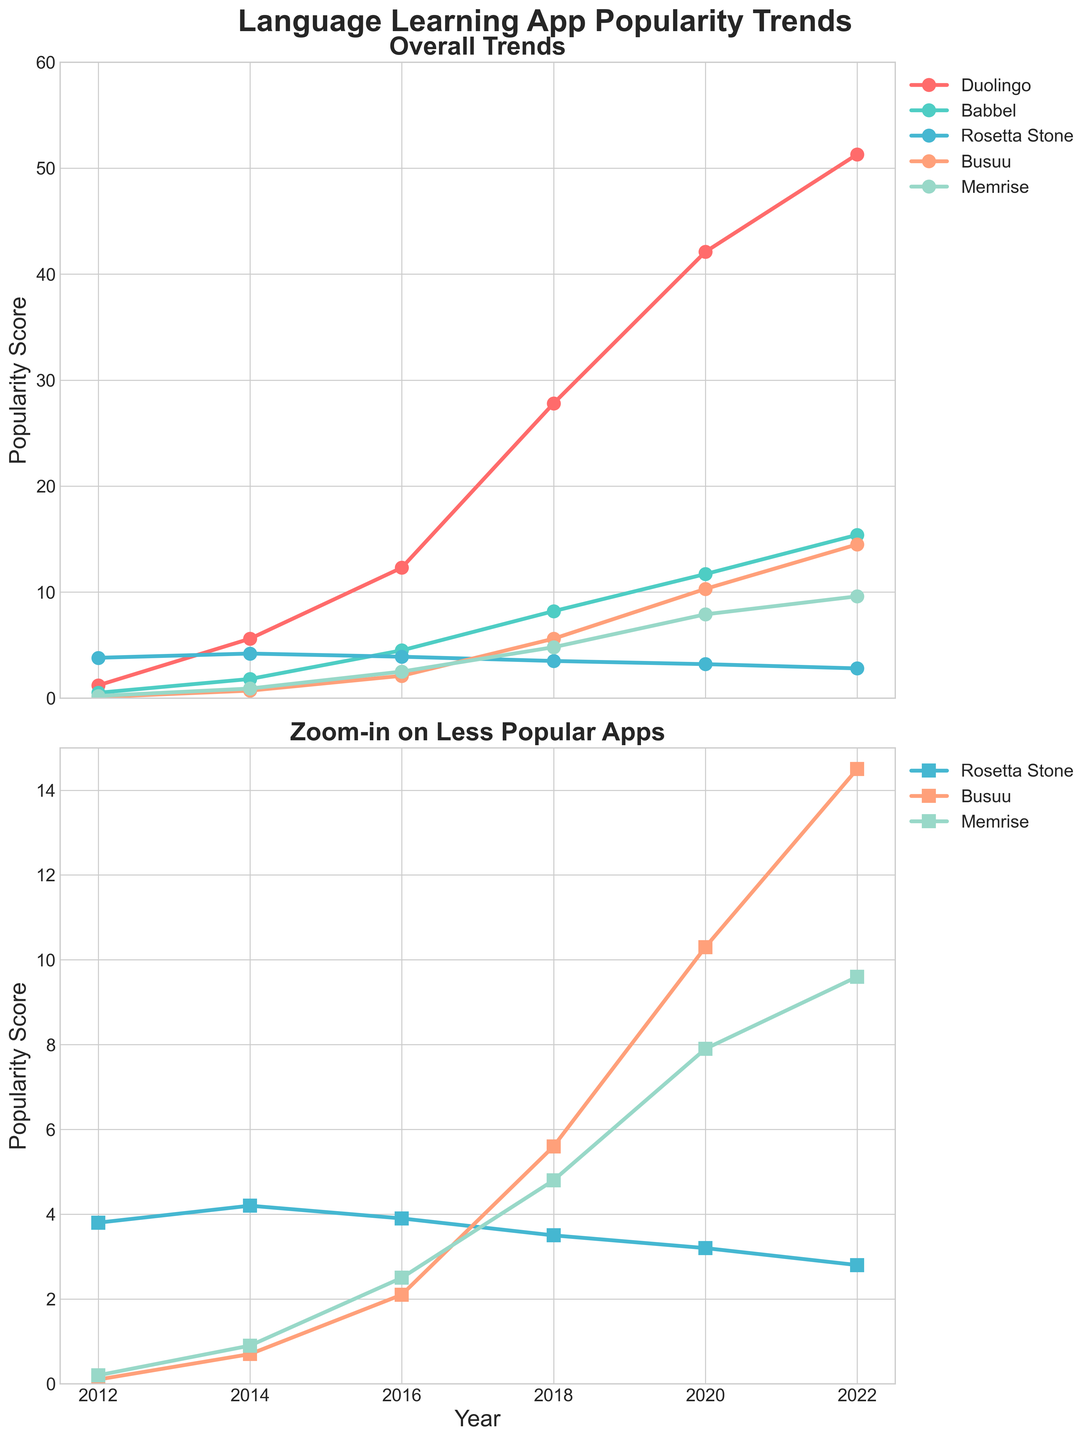What is the title of the figure? The title is located at the center top of the figure, it is bold and large, indicating the overall theme of the plots.
Answer: Language Learning App Popularity Trends How many subplots are there in the figure? The figure is divided into two parts; one can see two separate plots stacked vertically.
Answer: 2 Which app has the highest popularity score in 2022? Looking at the values along the vertical axis for the year 2022, Duolingo's series reaches the highest point among all others.
Answer: Duolingo How does the popularity of Rosetta Stone change from 2012 to 2022? Trace Rosetta Stone's line across the years on the vertical axis from 2012 to 2022; observe the decreasing trend.
Answer: It decreases What is the popularity score of Memrise in 2020? Locate the year 2020 on the horizontal axis and follow up to the corresponding value on Memrise’s line on the vertical axis.
Answer: 7.9 What is the difference between the popularity scores of Duolingo and Babbel in 2018? Find the scores of Duolingo (27.8) and Babbel (8.2) in 2018, then subtract Babbel's score from Duolingo's.
Answer: 19.6 Which app has the least variation in popularity between 2012 and 2022? Examine the overall trend lines for each app from 2012 to 2022 and identify the one with the smallest change in values. Rosetta Stone maintains a relatively steady, declining trend.
Answer: Rosetta Stone How many years of data are presented in the figure? Count the unique years along the horizontal axis; they represent the data points for each app.
Answer: 6 Between which consecutive years did Busuu see the most significant increase in popularity score? Calculate the differences in Busuu's scores between consecutive years and identify the largest increase. The increase from 2018 (5.6) to 2020 (10.3) is the most significant.
Answer: 2018 to 2020 